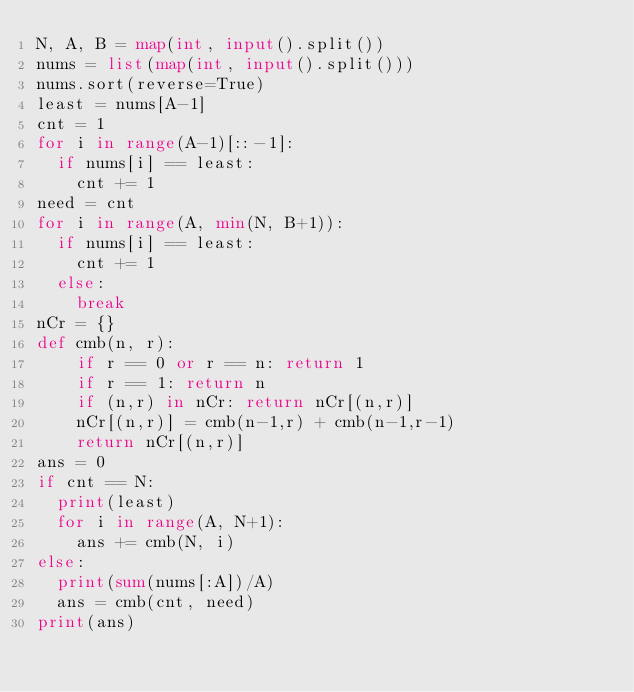Convert code to text. <code><loc_0><loc_0><loc_500><loc_500><_Python_>N, A, B = map(int, input().split())
nums = list(map(int, input().split()))
nums.sort(reverse=True)
least = nums[A-1]
cnt = 1
for i in range(A-1)[::-1]:
  if nums[i] == least:
    cnt += 1
need = cnt
for i in range(A, min(N, B+1)):
  if nums[i] == least:
    cnt += 1
  else:
    break
nCr = {}
def cmb(n, r):
    if r == 0 or r == n: return 1
    if r == 1: return n
    if (n,r) in nCr: return nCr[(n,r)]
    nCr[(n,r)] = cmb(n-1,r) + cmb(n-1,r-1)
    return nCr[(n,r)]
ans = 0
if cnt == N:
  print(least)
  for i in range(A, N+1):
    ans += cmb(N, i)
else:
  print(sum(nums[:A])/A)
  ans = cmb(cnt, need)
print(ans)
</code> 